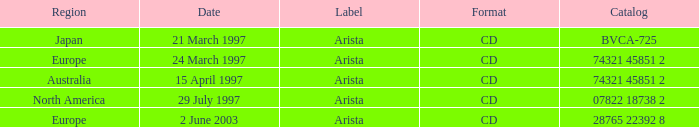What tag is assigned to the australian zone? Arista. 